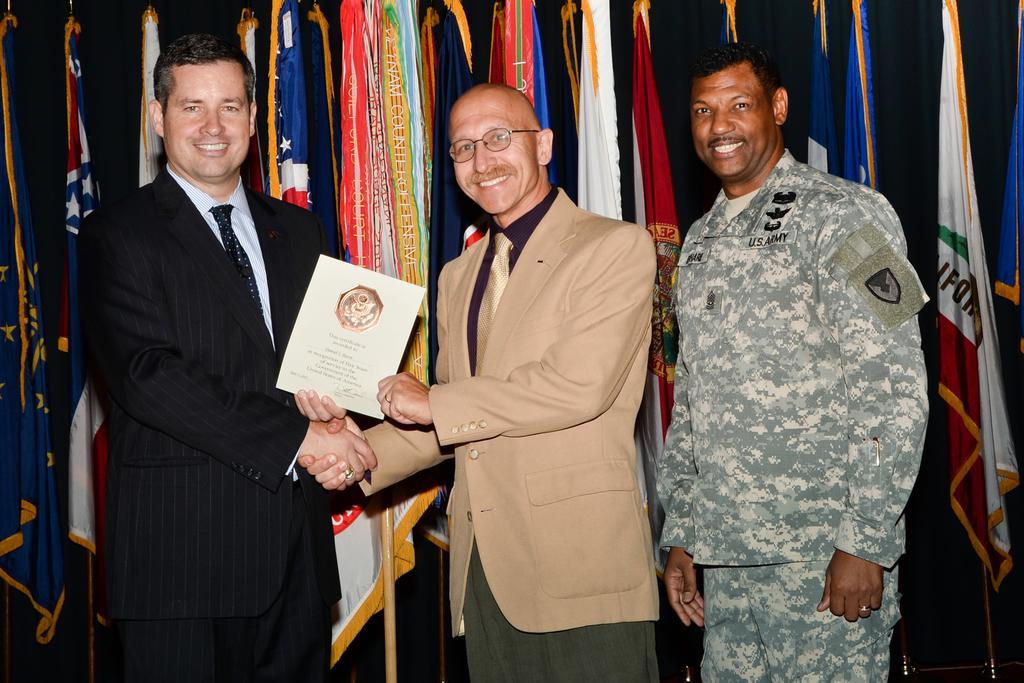Please provide a concise description of this image. In this image in the foreground there are three people standing, and talking two of them are holding book and they are shaking hands with each other and in the background there are some flags and poles and it seems that there is a curtain. 